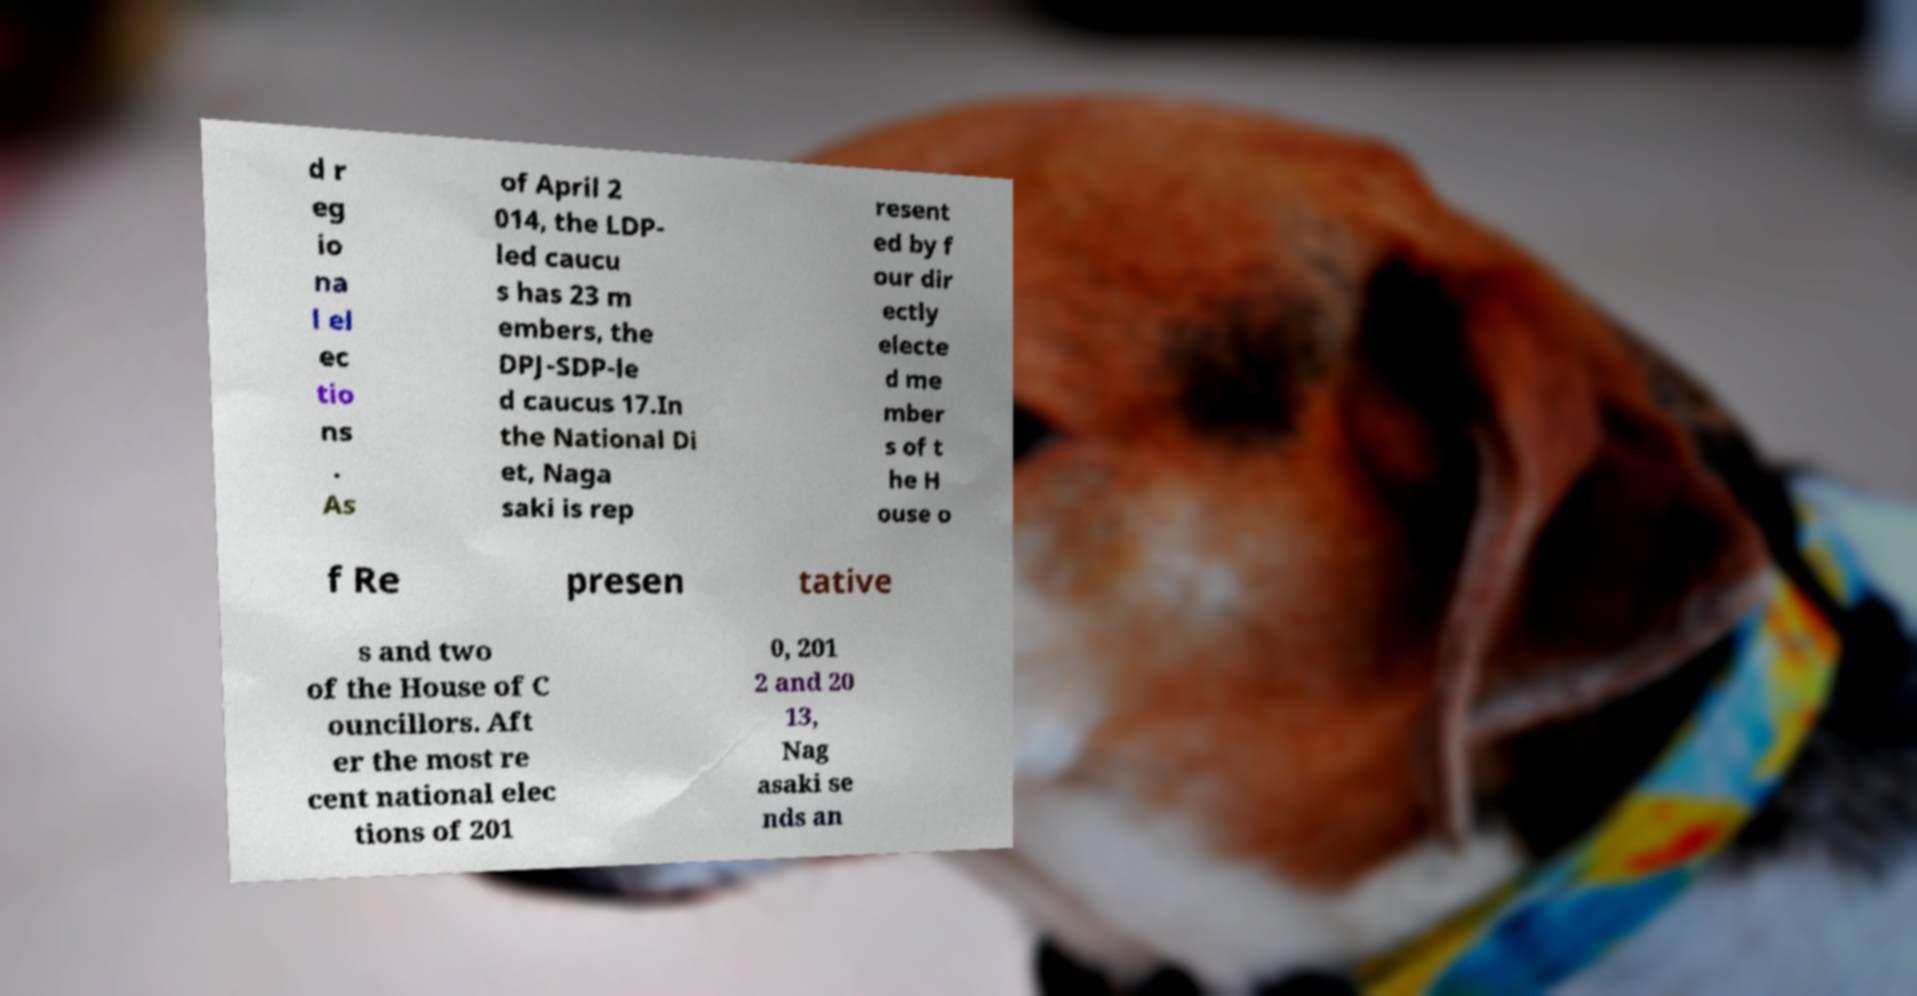I need the written content from this picture converted into text. Can you do that? d r eg io na l el ec tio ns . As of April 2 014, the LDP- led caucu s has 23 m embers, the DPJ-SDP-le d caucus 17.In the National Di et, Naga saki is rep resent ed by f our dir ectly electe d me mber s of t he H ouse o f Re presen tative s and two of the House of C ouncillors. Aft er the most re cent national elec tions of 201 0, 201 2 and 20 13, Nag asaki se nds an 